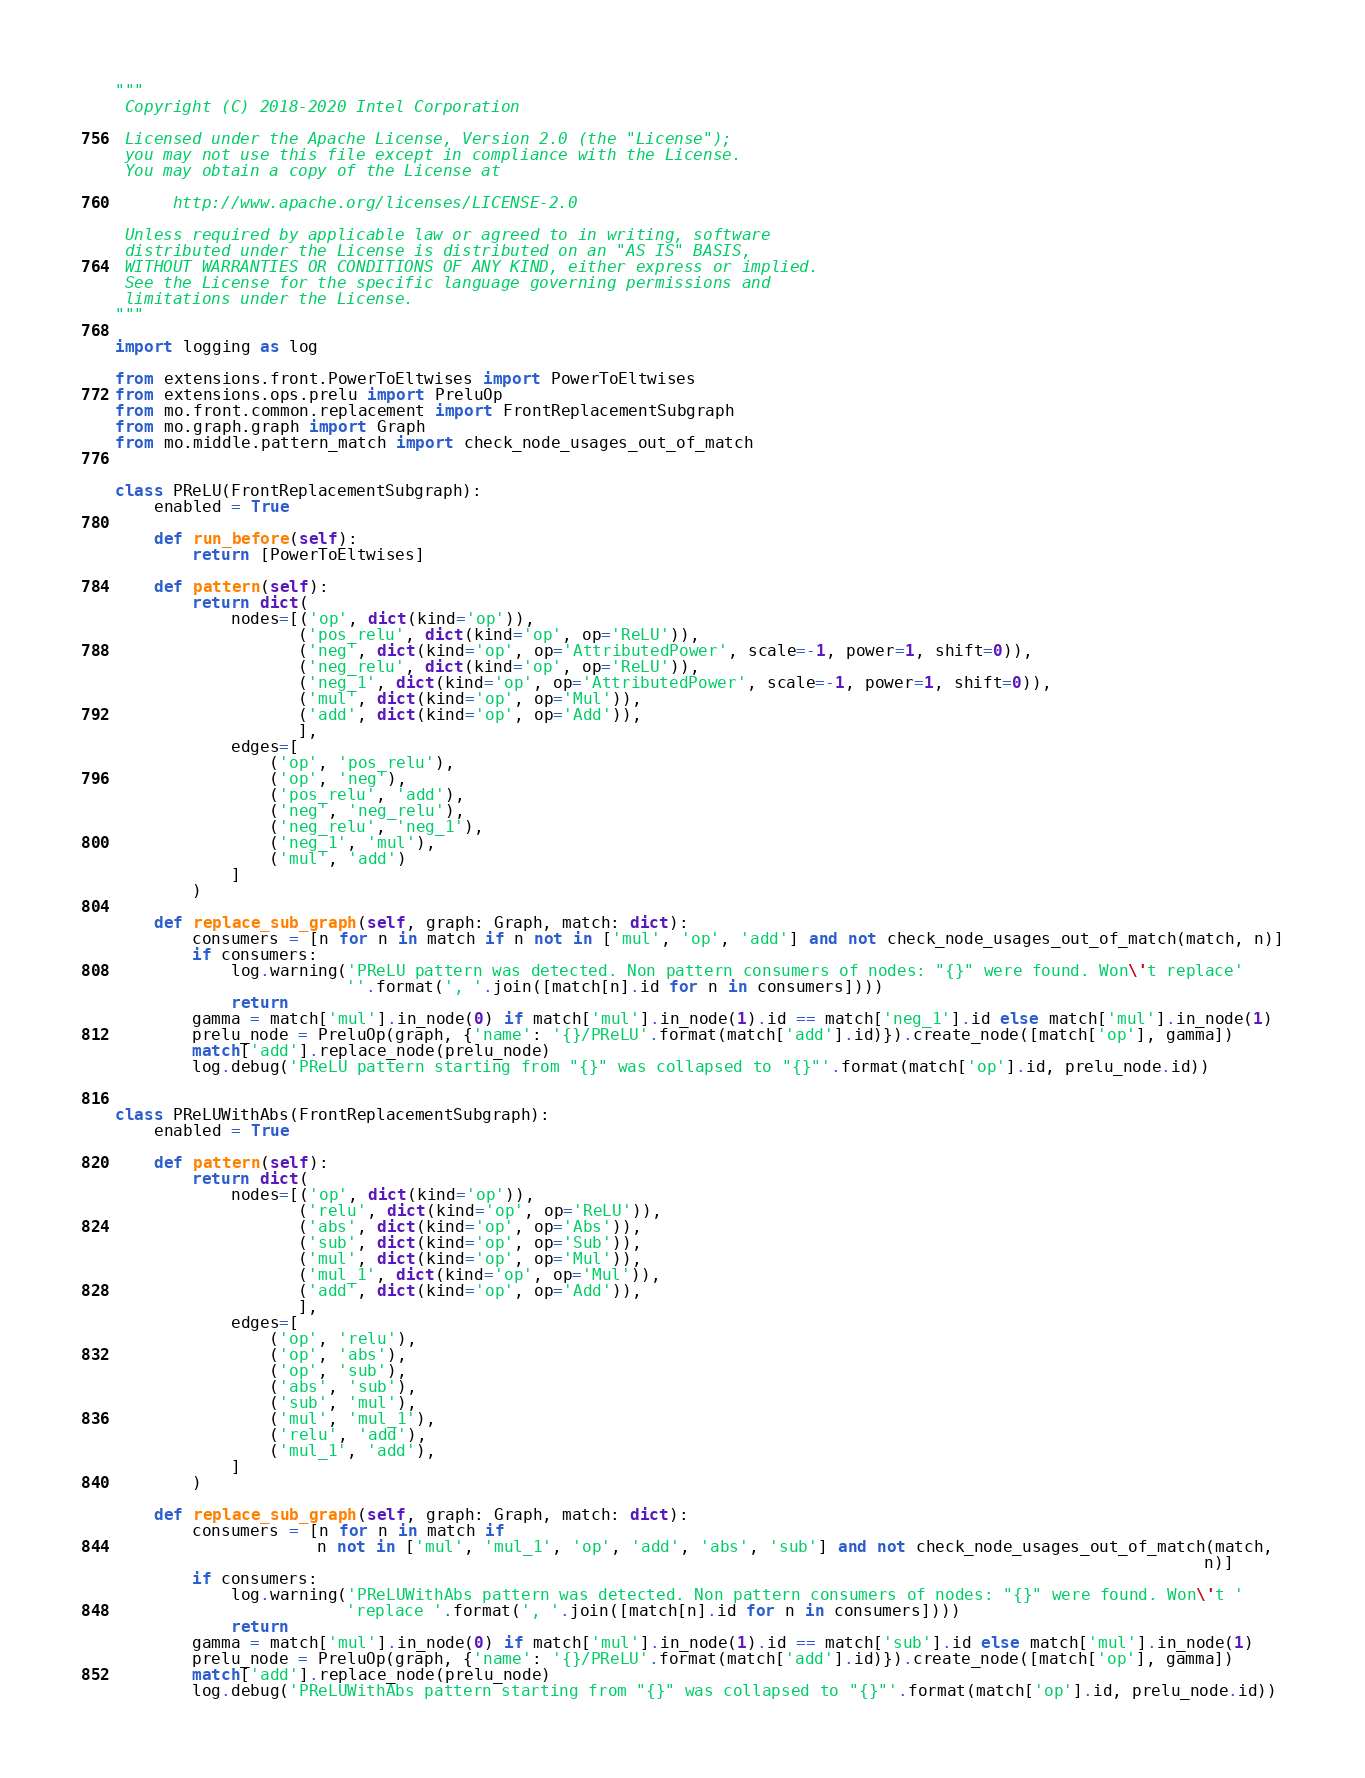Convert code to text. <code><loc_0><loc_0><loc_500><loc_500><_Python_>"""
 Copyright (C) 2018-2020 Intel Corporation

 Licensed under the Apache License, Version 2.0 (the "License");
 you may not use this file except in compliance with the License.
 You may obtain a copy of the License at

      http://www.apache.org/licenses/LICENSE-2.0

 Unless required by applicable law or agreed to in writing, software
 distributed under the License is distributed on an "AS IS" BASIS,
 WITHOUT WARRANTIES OR CONDITIONS OF ANY KIND, either express or implied.
 See the License for the specific language governing permissions and
 limitations under the License.
"""

import logging as log

from extensions.front.PowerToEltwises import PowerToEltwises
from extensions.ops.prelu import PreluOp
from mo.front.common.replacement import FrontReplacementSubgraph
from mo.graph.graph import Graph
from mo.middle.pattern_match import check_node_usages_out_of_match


class PReLU(FrontReplacementSubgraph):
    enabled = True

    def run_before(self):
        return [PowerToEltwises]

    def pattern(self):
        return dict(
            nodes=[('op', dict(kind='op')),
                   ('pos_relu', dict(kind='op', op='ReLU')),
                   ('neg', dict(kind='op', op='AttributedPower', scale=-1, power=1, shift=0)),
                   ('neg_relu', dict(kind='op', op='ReLU')),
                   ('neg_1', dict(kind='op', op='AttributedPower', scale=-1, power=1, shift=0)),
                   ('mul', dict(kind='op', op='Mul')),
                   ('add', dict(kind='op', op='Add')),
                   ],
            edges=[
                ('op', 'pos_relu'),
                ('op', 'neg'),
                ('pos_relu', 'add'),
                ('neg', 'neg_relu'),
                ('neg_relu', 'neg_1'),
                ('neg_1', 'mul'),
                ('mul', 'add')
            ]
        )

    def replace_sub_graph(self, graph: Graph, match: dict):
        consumers = [n for n in match if n not in ['mul', 'op', 'add'] and not check_node_usages_out_of_match(match, n)]
        if consumers:
            log.warning('PReLU pattern was detected. Non pattern consumers of nodes: "{}" were found. Won\'t replace'
                        ''.format(', '.join([match[n].id for n in consumers])))
            return
        gamma = match['mul'].in_node(0) if match['mul'].in_node(1).id == match['neg_1'].id else match['mul'].in_node(1)
        prelu_node = PreluOp(graph, {'name': '{}/PReLU'.format(match['add'].id)}).create_node([match['op'], gamma])
        match['add'].replace_node(prelu_node)
        log.debug('PReLU pattern starting from "{}" was collapsed to "{}"'.format(match['op'].id, prelu_node.id))


class PReLUWithAbs(FrontReplacementSubgraph):
    enabled = True

    def pattern(self):
        return dict(
            nodes=[('op', dict(kind='op')),
                   ('relu', dict(kind='op', op='ReLU')),
                   ('abs', dict(kind='op', op='Abs')),
                   ('sub', dict(kind='op', op='Sub')),
                   ('mul', dict(kind='op', op='Mul')),
                   ('mul_1', dict(kind='op', op='Mul')),
                   ('add', dict(kind='op', op='Add')),
                   ],
            edges=[
                ('op', 'relu'),
                ('op', 'abs'),
                ('op', 'sub'),
                ('abs', 'sub'),
                ('sub', 'mul'),
                ('mul', 'mul_1'),
                ('relu', 'add'),
                ('mul_1', 'add'),
            ]
        )

    def replace_sub_graph(self, graph: Graph, match: dict):
        consumers = [n for n in match if
                     n not in ['mul', 'mul_1', 'op', 'add', 'abs', 'sub'] and not check_node_usages_out_of_match(match,
                                                                                                                 n)]
        if consumers:
            log.warning('PReLUWithAbs pattern was detected. Non pattern consumers of nodes: "{}" were found. Won\'t '
                        'replace '.format(', '.join([match[n].id for n in consumers])))
            return
        gamma = match['mul'].in_node(0) if match['mul'].in_node(1).id == match['sub'].id else match['mul'].in_node(1)
        prelu_node = PreluOp(graph, {'name': '{}/PReLU'.format(match['add'].id)}).create_node([match['op'], gamma])
        match['add'].replace_node(prelu_node)
        log.debug('PReLUWithAbs pattern starting from "{}" was collapsed to "{}"'.format(match['op'].id, prelu_node.id))
</code> 